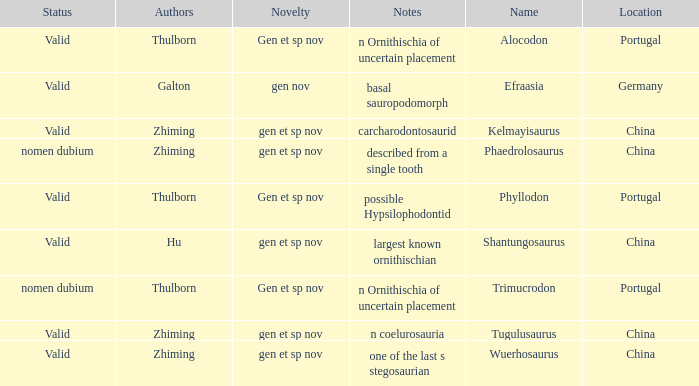What is the Status of the dinosaur, whose notes are, "n coelurosauria"? Valid. 